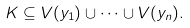Convert formula to latex. <formula><loc_0><loc_0><loc_500><loc_500>K \subseteq V ( y _ { 1 } ) \cup \cdots \cup V ( y _ { n } ) .</formula> 